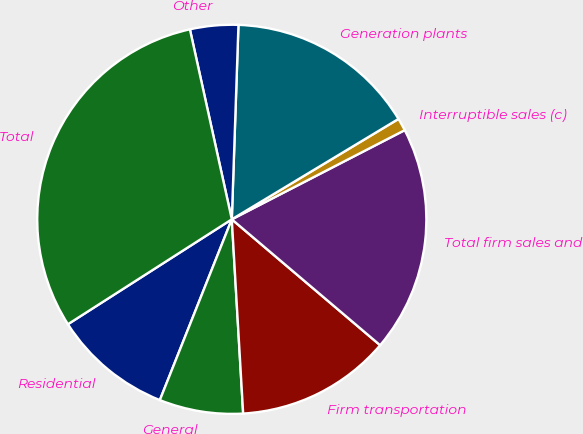Convert chart to OTSL. <chart><loc_0><loc_0><loc_500><loc_500><pie_chart><fcel>Residential<fcel>General<fcel>Firm transportation<fcel>Total firm sales and<fcel>Interruptible sales (c)<fcel>Generation plants<fcel>Other<fcel>Total<nl><fcel>9.91%<fcel>6.96%<fcel>12.87%<fcel>18.78%<fcel>1.05%<fcel>15.83%<fcel>4.0%<fcel>30.61%<nl></chart> 